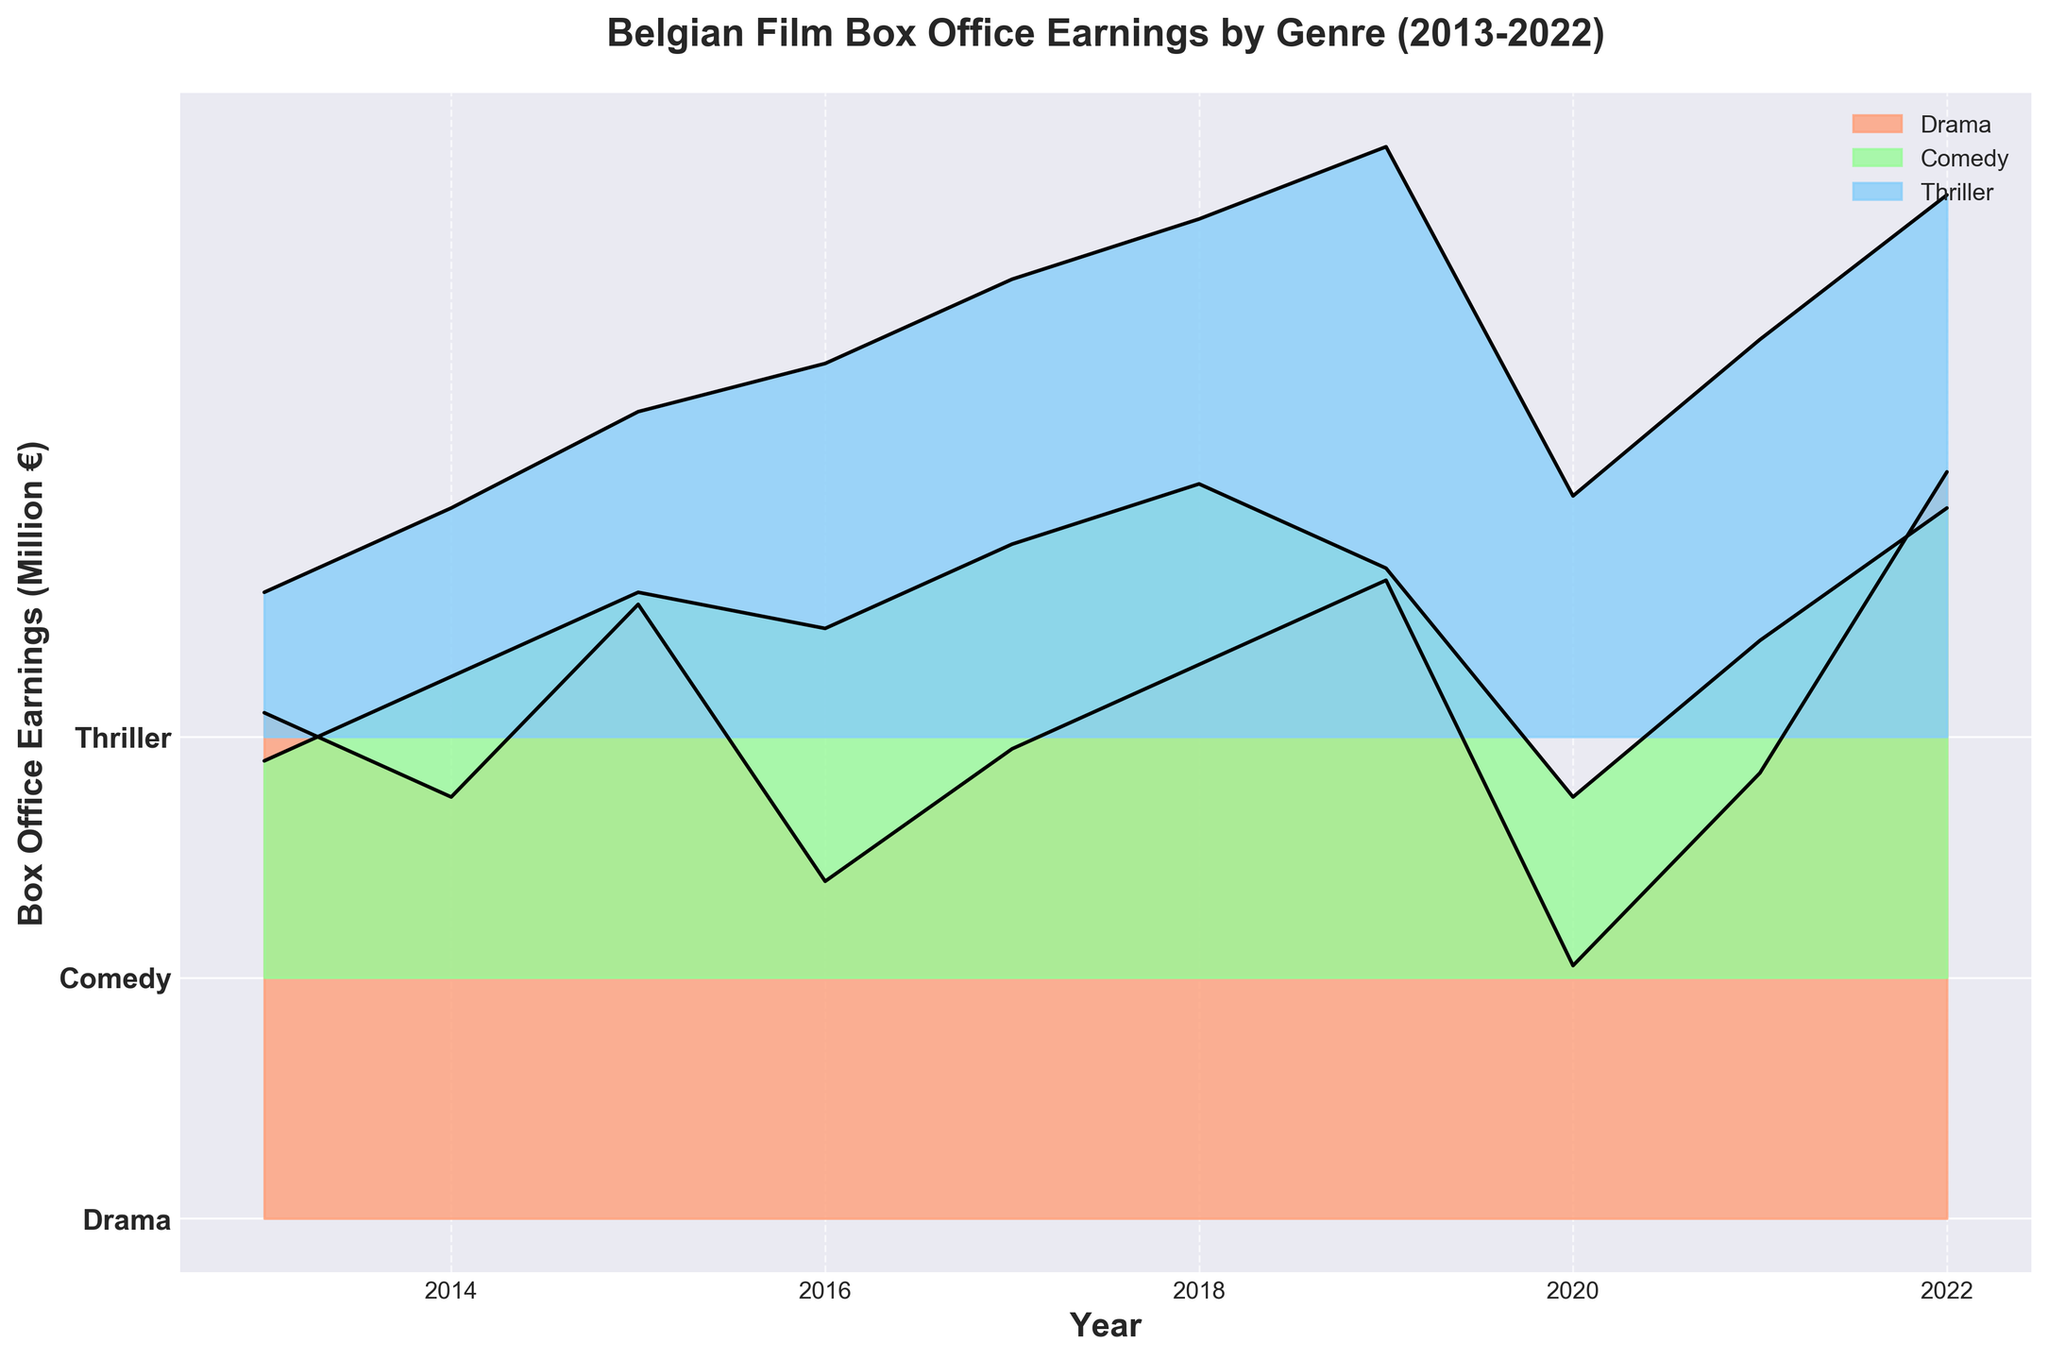What's the title of the plot? The title of the plot is located at the top of the figure. It is clearly stated and easy to identify.
Answer: Belgian Film Box Office Earnings by Genre (2013-2022) Which genre had the highest box office earnings in 2019? Look at the 2019 data points for each genre and compare their heights on the y-axis to find the highest one. Drama has the highest peak at 5300000 Euros.
Answer: Drama Which genre appears in the green color on the plot? Looking at the green color in the legend or the plot itself, we see that it corresponds to the Comedy genre.
Answer: Comedy How many unique genres are presented in the plot? The number of unique genres can be identified by counting the distinct y-tick labels on the plot. There are 3 distinct genres listed.
Answer: 3 What was the box office earning for thrillers in the year 2018? Locate the thriller genre on the y-axis, move vertically to the year 2018, and observe the height of the curve. The peak value at that point is 4300000 Euros.
Answer: 4300000 Euros What is the box office earnings range for dramas in all the years? Identify the minimum and maximum box office earnings for dramas from the plot by comparing the lowest and highest points of the drama curve. The range is from 2100000 to 6200000 Euros.
Answer: 2100000 to 6200000 Euros Which genre shows the most consistent box office earnings across the years? Compare the steadiness of the curves for each genre year over year. The Comedy genre shows the least variation, indicating consistency.
Answer: Comedy In which year did thriller films see the highest box office earnings? Look at the thriller genre and identify the highest peak over the timeline. The highest point for thrillers is in 2019 with 4900000 Euros.
Answer: 2019 How does the box office earnings of drama films in 2022 compare to comedy films in the same year? Compare the height of the 2022 data points for both drama and comedy genres. Drama's 2022 earnings are higher (6200000 Euros) compared to Comedy (3900000 Euros).
Answer: Drama had higher earnings Which genre had the lowest box office earnings in 2013? By comparing the heights of the 2013 data points for each genre, we observe that Thriller has the lowest earnings at 1200000 Euros.
Answer: Thriller 